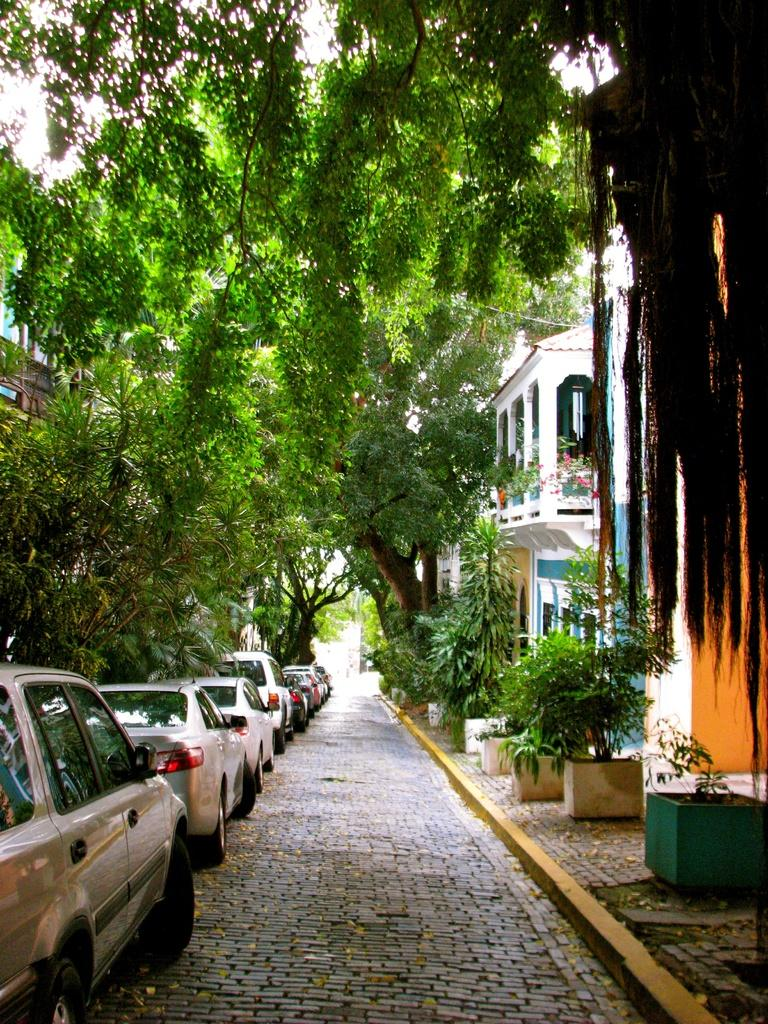What can be seen on the floor in the image? There are cars parked on the floor in the image. What structures are visible in the image? There are buildings visible in the image. What type of vegetation is in front of the buildings? There are trees in front of the buildings in the image. What type of plants are present in the image? There are potted plants in the image. Can you see a twig being used as a garden arch in the image? There is no twig or garden arch present in the image. What type of flowers are planted around the arch in the image? There is no arch or flowers present in the image. 